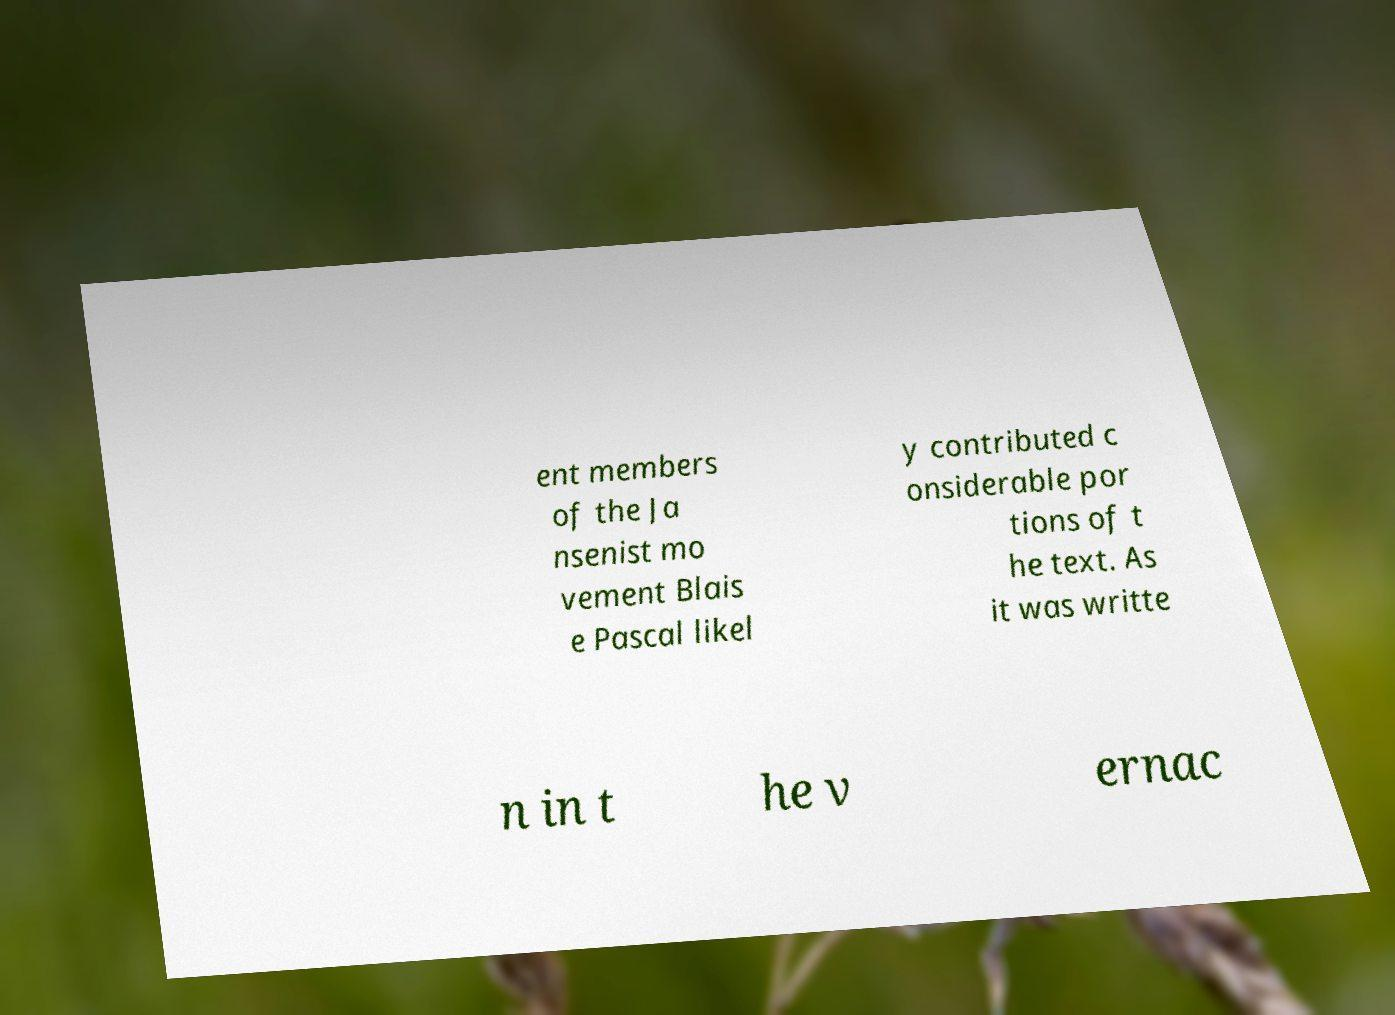What messages or text are displayed in this image? I need them in a readable, typed format. ent members of the Ja nsenist mo vement Blais e Pascal likel y contributed c onsiderable por tions of t he text. As it was writte n in t he v ernac 